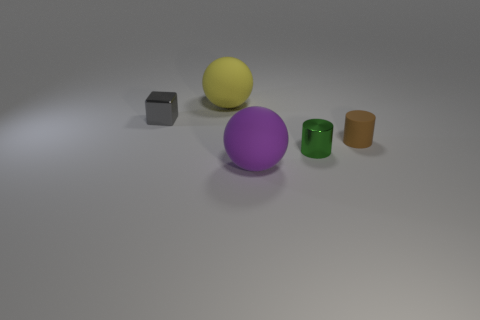Add 5 red blocks. How many objects exist? 10 Subtract all blocks. How many objects are left? 4 Subtract 0 gray spheres. How many objects are left? 5 Subtract all matte things. Subtract all big matte cubes. How many objects are left? 2 Add 2 purple rubber objects. How many purple rubber objects are left? 3 Add 2 objects. How many objects exist? 7 